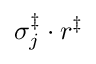Convert formula to latex. <formula><loc_0><loc_0><loc_500><loc_500>\sigma _ { j } ^ { \ddag } \cdot r ^ { \ddag }</formula> 